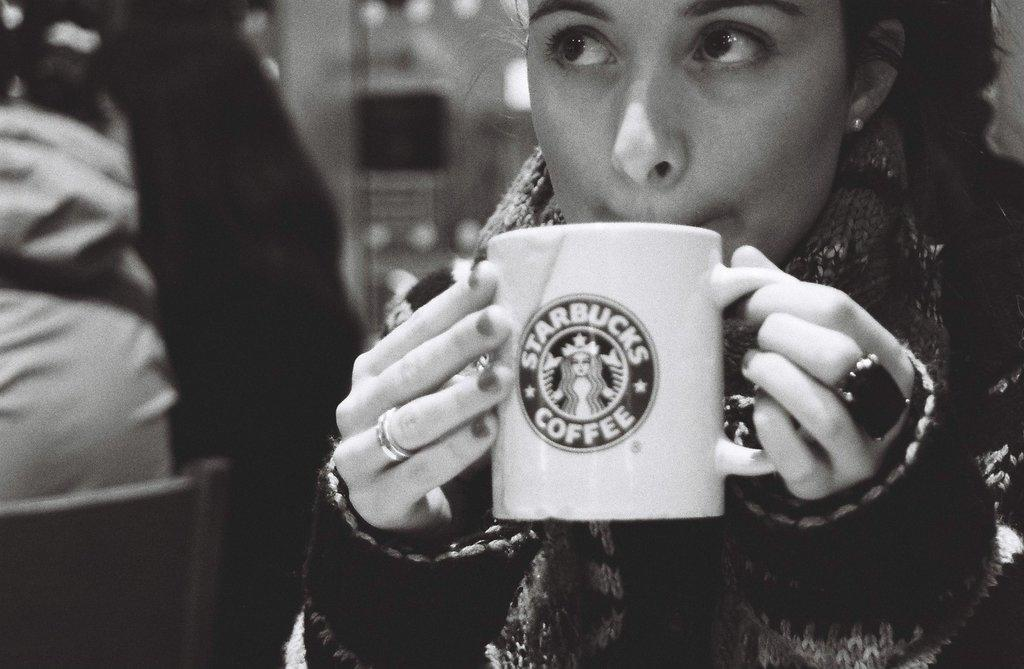What is present in the image? There is a person in the image. What is the person wearing? The person is wearing a black dress. What is the person doing in the image? The person is drinking coffee. Where is the secretary's nest located in the image? There is no secretary or nest present in the image. 